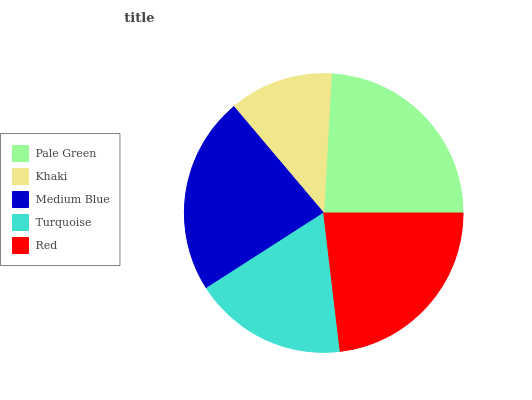Is Khaki the minimum?
Answer yes or no. Yes. Is Pale Green the maximum?
Answer yes or no. Yes. Is Medium Blue the minimum?
Answer yes or no. No. Is Medium Blue the maximum?
Answer yes or no. No. Is Medium Blue greater than Khaki?
Answer yes or no. Yes. Is Khaki less than Medium Blue?
Answer yes or no. Yes. Is Khaki greater than Medium Blue?
Answer yes or no. No. Is Medium Blue less than Khaki?
Answer yes or no. No. Is Medium Blue the high median?
Answer yes or no. Yes. Is Medium Blue the low median?
Answer yes or no. Yes. Is Khaki the high median?
Answer yes or no. No. Is Red the low median?
Answer yes or no. No. 